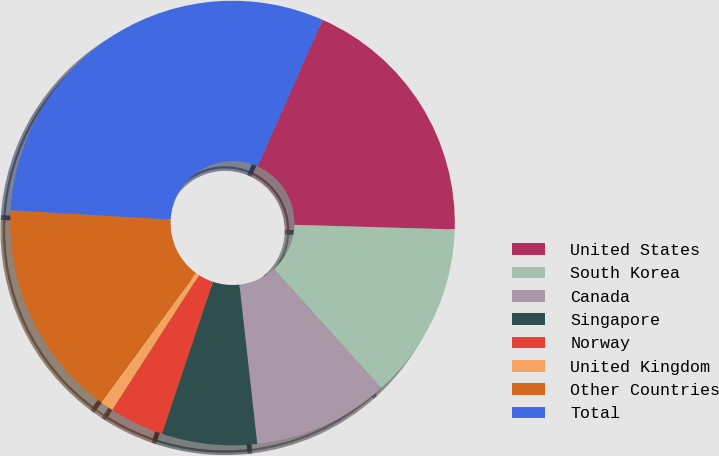Convert chart to OTSL. <chart><loc_0><loc_0><loc_500><loc_500><pie_chart><fcel>United States<fcel>South Korea<fcel>Canada<fcel>Singapore<fcel>Norway<fcel>United Kingdom<fcel>Other Countries<fcel>Total<nl><fcel>18.82%<fcel>12.87%<fcel>9.9%<fcel>6.92%<fcel>3.95%<fcel>0.97%<fcel>15.85%<fcel>30.72%<nl></chart> 